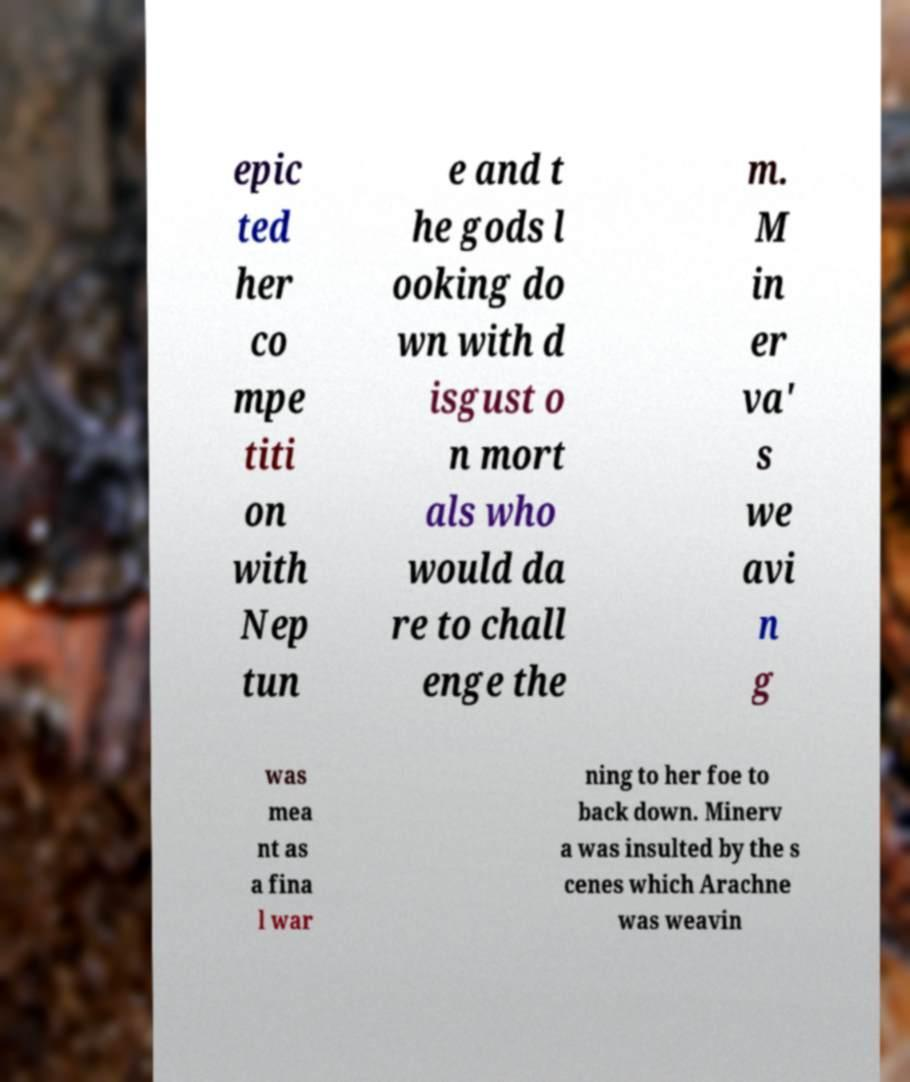Please identify and transcribe the text found in this image. epic ted her co mpe titi on with Nep tun e and t he gods l ooking do wn with d isgust o n mort als who would da re to chall enge the m. M in er va' s we avi n g was mea nt as a fina l war ning to her foe to back down. Minerv a was insulted by the s cenes which Arachne was weavin 